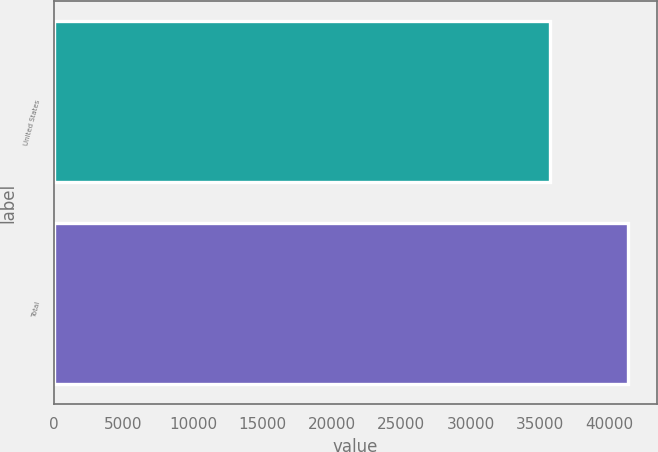Convert chart. <chart><loc_0><loc_0><loc_500><loc_500><bar_chart><fcel>United States<fcel>Total<nl><fcel>35715<fcel>41373<nl></chart> 